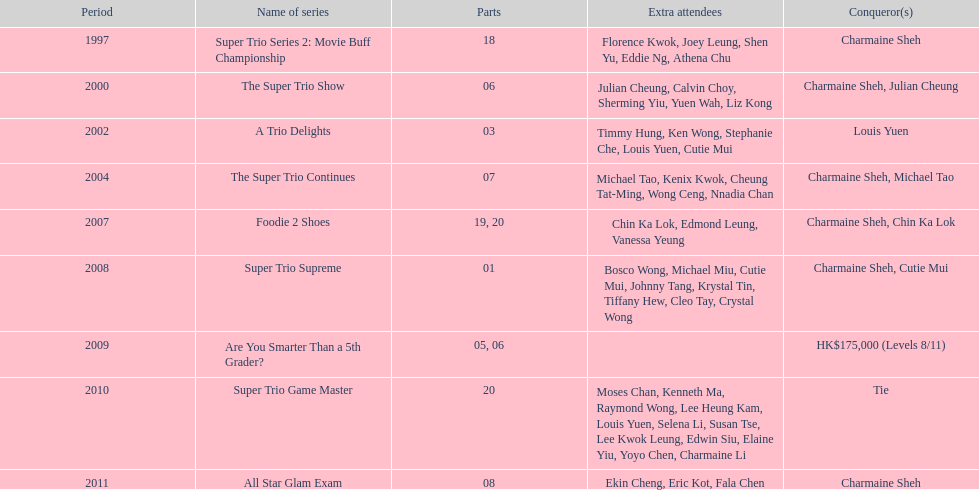What is the number of other guests in the 2002 show "a trio delights"? 5. 